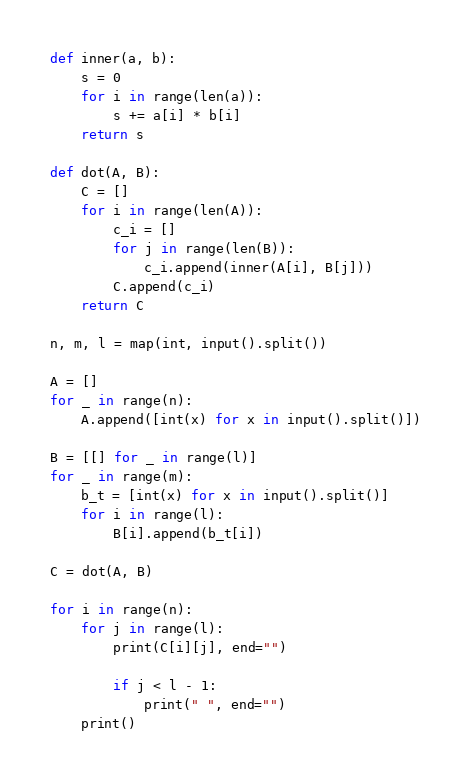Convert code to text. <code><loc_0><loc_0><loc_500><loc_500><_Python_>def inner(a, b):
    s = 0
    for i in range(len(a)):
        s += a[i] * b[i]
    return s

def dot(A, B):
    C = []
    for i in range(len(A)):
        c_i = []
        for j in range(len(B)):
            c_i.append(inner(A[i], B[j]))
        C.append(c_i)
    return C

n, m, l = map(int, input().split())

A = []
for _ in range(n):
    A.append([int(x) for x in input().split()])

B = [[] for _ in range(l)]
for _ in range(m):
    b_t = [int(x) for x in input().split()]
    for i in range(l):
        B[i].append(b_t[i])
        
C = dot(A, B)

for i in range(n):
    for j in range(l):
        print(C[i][j], end="")
        
        if j < l - 1:
            print(" ", end="")
    print()

</code> 